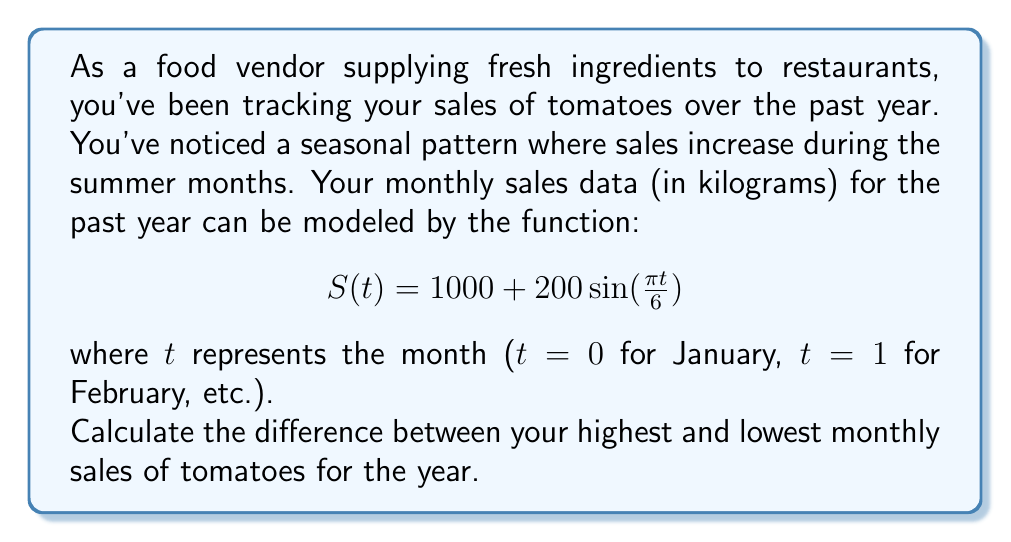Teach me how to tackle this problem. To solve this problem, we need to find the maximum and minimum values of the function $S(t)$ over the course of a year (12 months).

1) The function $S(t) = 1000 + 200\sin(\frac{\pi t}{6})$ is a sinusoidal function with:
   - Midline at y = 1000
   - Amplitude of 200

2) The maximum value occurs when $\sin(\frac{\pi t}{6}) = 1$, and the minimum value occurs when $\sin(\frac{\pi t}{6}) = -1$.

3) Maximum value:
   $$S_{max} = 1000 + 200(1) = 1200$$

4) Minimum value:
   $$S_{min} = 1000 + 200(-1) = 800$$

5) The difference between the highest and lowest monthly sales is:
   $$S_{max} - S_{min} = 1200 - 800 = 400$$

Therefore, the difference between the highest and lowest monthly sales of tomatoes for the year is 400 kg.
Answer: 400 kg 